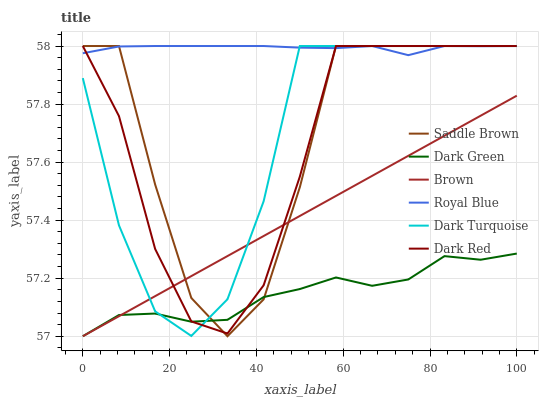Does Dark Green have the minimum area under the curve?
Answer yes or no. Yes. Does Royal Blue have the maximum area under the curve?
Answer yes or no. Yes. Does Dark Red have the minimum area under the curve?
Answer yes or no. No. Does Dark Red have the maximum area under the curve?
Answer yes or no. No. Is Brown the smoothest?
Answer yes or no. Yes. Is Saddle Brown the roughest?
Answer yes or no. Yes. Is Dark Red the smoothest?
Answer yes or no. No. Is Dark Red the roughest?
Answer yes or no. No. Does Brown have the lowest value?
Answer yes or no. Yes. Does Dark Red have the lowest value?
Answer yes or no. No. Does Saddle Brown have the highest value?
Answer yes or no. Yes. Does Dark Green have the highest value?
Answer yes or no. No. Is Dark Green less than Royal Blue?
Answer yes or no. Yes. Is Royal Blue greater than Brown?
Answer yes or no. Yes. Does Dark Green intersect Dark Turquoise?
Answer yes or no. Yes. Is Dark Green less than Dark Turquoise?
Answer yes or no. No. Is Dark Green greater than Dark Turquoise?
Answer yes or no. No. Does Dark Green intersect Royal Blue?
Answer yes or no. No. 